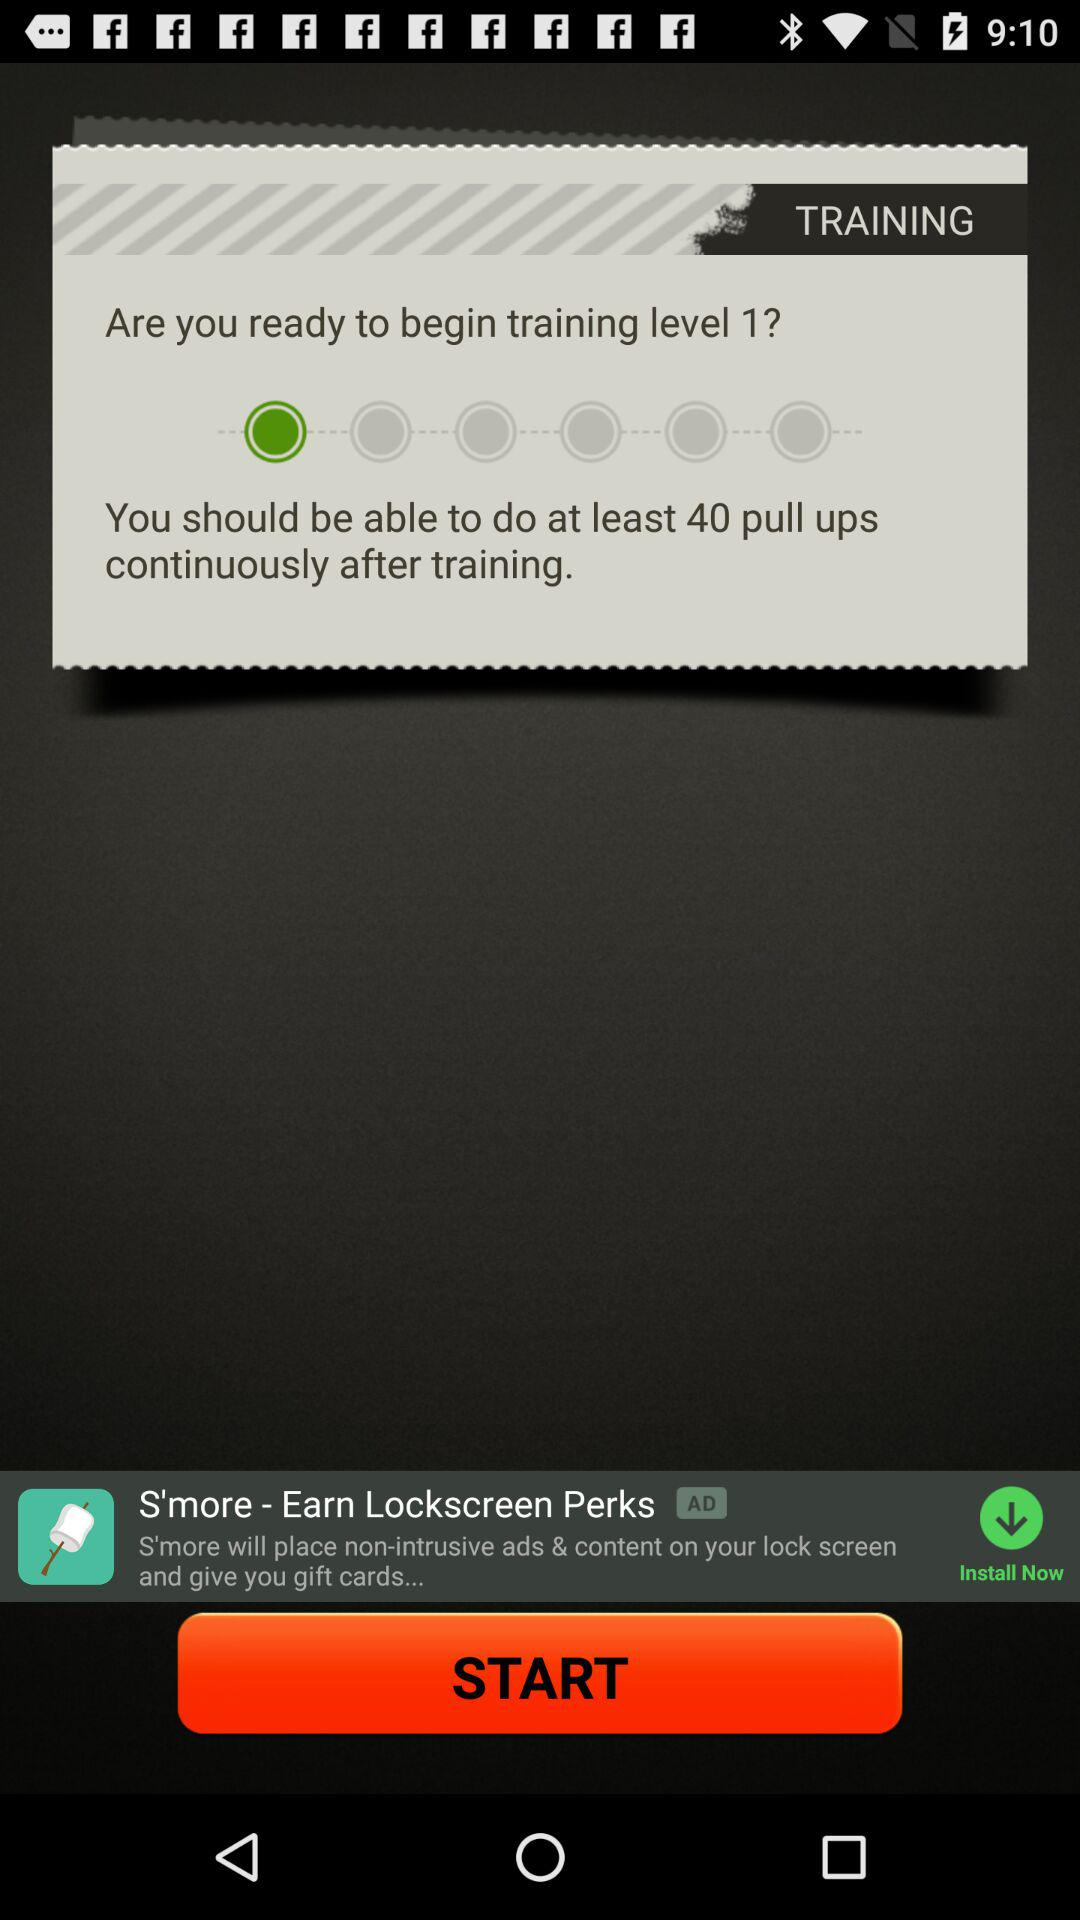Which level has been mentioned for training? The mentioned level for training is 1. 